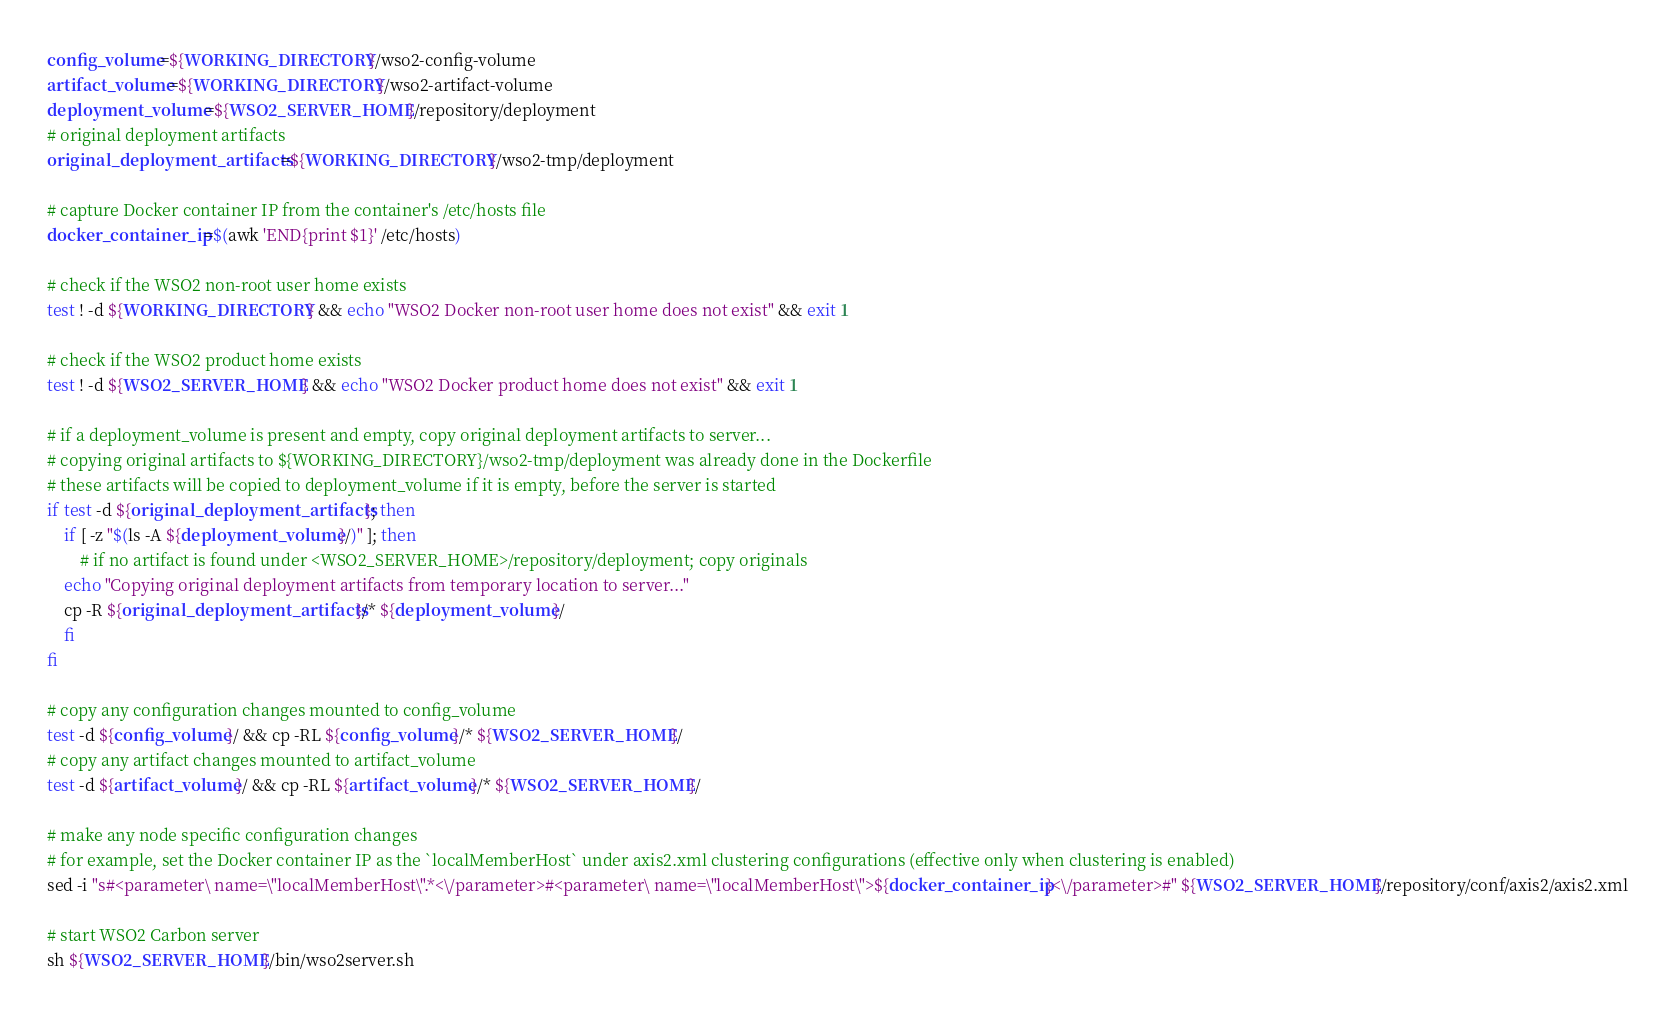<code> <loc_0><loc_0><loc_500><loc_500><_Bash_>config_volume=${WORKING_DIRECTORY}/wso2-config-volume
artifact_volume=${WORKING_DIRECTORY}/wso2-artifact-volume
deployment_volume=${WSO2_SERVER_HOME}/repository/deployment
# original deployment artifacts
original_deployment_artifacts=${WORKING_DIRECTORY}/wso2-tmp/deployment

# capture Docker container IP from the container's /etc/hosts file
docker_container_ip=$(awk 'END{print $1}' /etc/hosts)

# check if the WSO2 non-root user home exists
test ! -d ${WORKING_DIRECTORY} && echo "WSO2 Docker non-root user home does not exist" && exit 1

# check if the WSO2 product home exists
test ! -d ${WSO2_SERVER_HOME} && echo "WSO2 Docker product home does not exist" && exit 1

# if a deployment_volume is present and empty, copy original deployment artifacts to server...
# copying original artifacts to ${WORKING_DIRECTORY}/wso2-tmp/deployment was already done in the Dockerfile
# these artifacts will be copied to deployment_volume if it is empty, before the server is started
if test -d ${original_deployment_artifacts}; then
    if [ -z "$(ls -A ${deployment_volume}/)" ]; then
	    # if no artifact is found under <WSO2_SERVER_HOME>/repository/deployment; copy originals
	echo "Copying original deployment artifacts from temporary location to server..."
	cp -R ${original_deployment_artifacts}/* ${deployment_volume}/
    fi
fi

# copy any configuration changes mounted to config_volume
test -d ${config_volume}/ && cp -RL ${config_volume}/* ${WSO2_SERVER_HOME}/
# copy any artifact changes mounted to artifact_volume
test -d ${artifact_volume}/ && cp -RL ${artifact_volume}/* ${WSO2_SERVER_HOME}/

# make any node specific configuration changes
# for example, set the Docker container IP as the `localMemberHost` under axis2.xml clustering configurations (effective only when clustering is enabled)
sed -i "s#<parameter\ name=\"localMemberHost\".*<\/parameter>#<parameter\ name=\"localMemberHost\">${docker_container_ip}<\/parameter>#" ${WSO2_SERVER_HOME}/repository/conf/axis2/axis2.xml

# start WSO2 Carbon server
sh ${WSO2_SERVER_HOME}/bin/wso2server.sh
</code> 